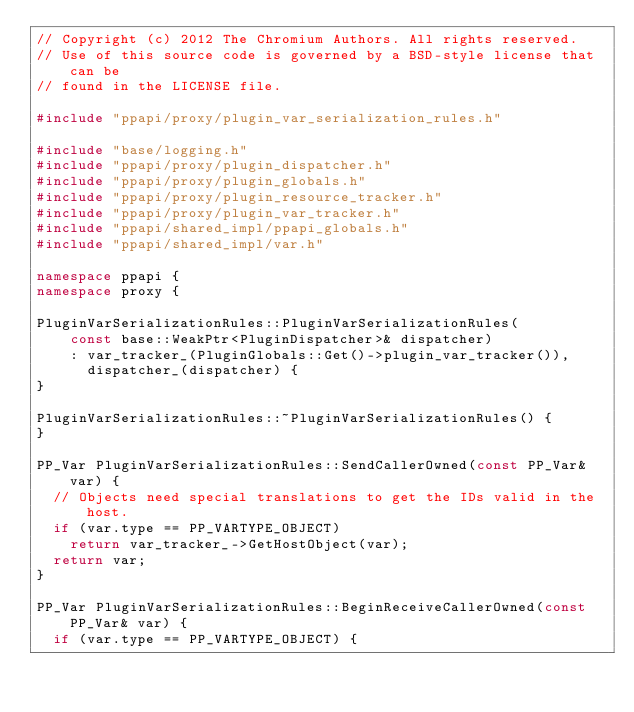Convert code to text. <code><loc_0><loc_0><loc_500><loc_500><_C++_>// Copyright (c) 2012 The Chromium Authors. All rights reserved.
// Use of this source code is governed by a BSD-style license that can be
// found in the LICENSE file.

#include "ppapi/proxy/plugin_var_serialization_rules.h"

#include "base/logging.h"
#include "ppapi/proxy/plugin_dispatcher.h"
#include "ppapi/proxy/plugin_globals.h"
#include "ppapi/proxy/plugin_resource_tracker.h"
#include "ppapi/proxy/plugin_var_tracker.h"
#include "ppapi/shared_impl/ppapi_globals.h"
#include "ppapi/shared_impl/var.h"

namespace ppapi {
namespace proxy {

PluginVarSerializationRules::PluginVarSerializationRules(
    const base::WeakPtr<PluginDispatcher>& dispatcher)
    : var_tracker_(PluginGlobals::Get()->plugin_var_tracker()),
      dispatcher_(dispatcher) {
}

PluginVarSerializationRules::~PluginVarSerializationRules() {
}

PP_Var PluginVarSerializationRules::SendCallerOwned(const PP_Var& var) {
  // Objects need special translations to get the IDs valid in the host.
  if (var.type == PP_VARTYPE_OBJECT)
    return var_tracker_->GetHostObject(var);
  return var;
}

PP_Var PluginVarSerializationRules::BeginReceiveCallerOwned(const PP_Var& var) {
  if (var.type == PP_VARTYPE_OBJECT) {</code> 